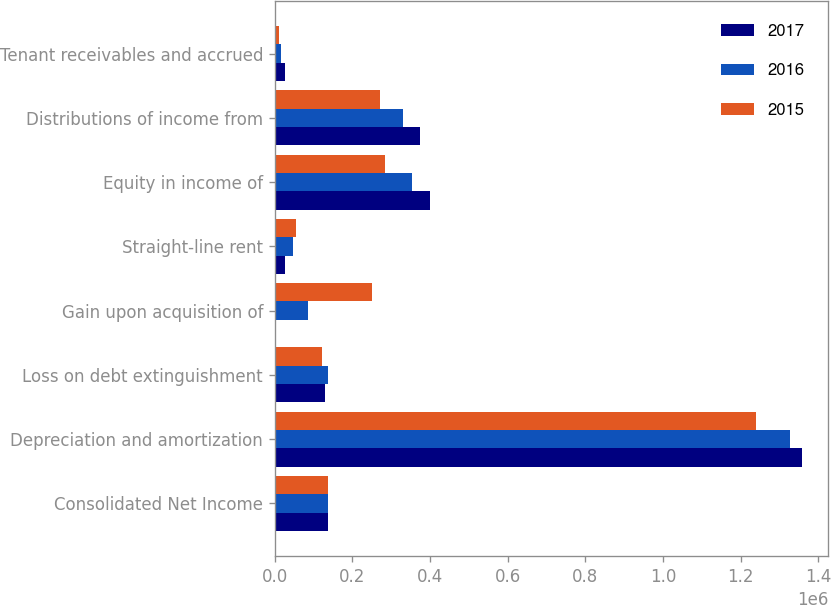Convert chart. <chart><loc_0><loc_0><loc_500><loc_500><stacked_bar_chart><ecel><fcel>Consolidated Net Income<fcel>Depreciation and amortization<fcel>Loss on debt extinguishment<fcel>Gain upon acquisition of<fcel>Straight-line rent<fcel>Equity in income of<fcel>Distributions of income from<fcel>Tenant receivables and accrued<nl><fcel>2017<fcel>136777<fcel>1.35735e+06<fcel>128618<fcel>3647<fcel>26543<fcel>400270<fcel>374101<fcel>26170<nl><fcel>2016<fcel>136777<fcel>1.32795e+06<fcel>136777<fcel>84553<fcel>46656<fcel>353334<fcel>331627<fcel>16277<nl><fcel>2015<fcel>136777<fcel>1.23921e+06<fcel>120953<fcel>250516<fcel>54129<fcel>284806<fcel>271998<fcel>9918<nl></chart> 